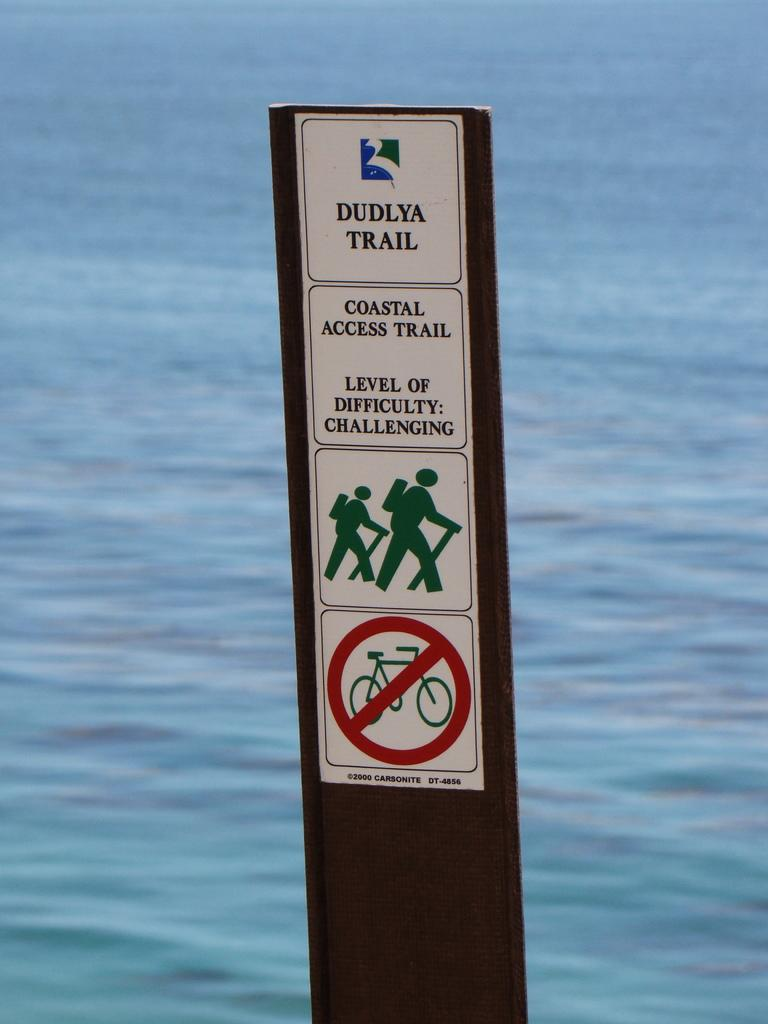What is the main object in the image? There is a sign board in the image. What is on the sign board? The sign board has caution stickers on it. What can be seen behind the sign board? There is water visible behind the sign board. What is the sign board is generating a profit in the image? There is no information about profit in the image; it only shows a sign board with caution stickers and water in the background. 